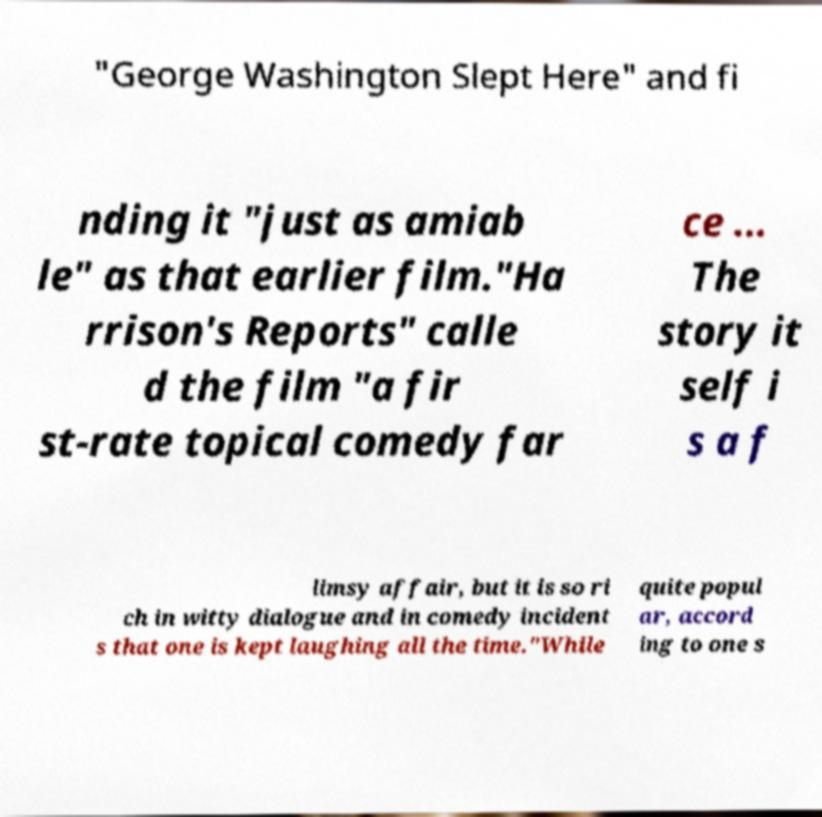Please read and relay the text visible in this image. What does it say? "George Washington Slept Here" and fi nding it "just as amiab le" as that earlier film."Ha rrison's Reports" calle d the film "a fir st-rate topical comedy far ce ... The story it self i s a f limsy affair, but it is so ri ch in witty dialogue and in comedy incident s that one is kept laughing all the time."While quite popul ar, accord ing to one s 